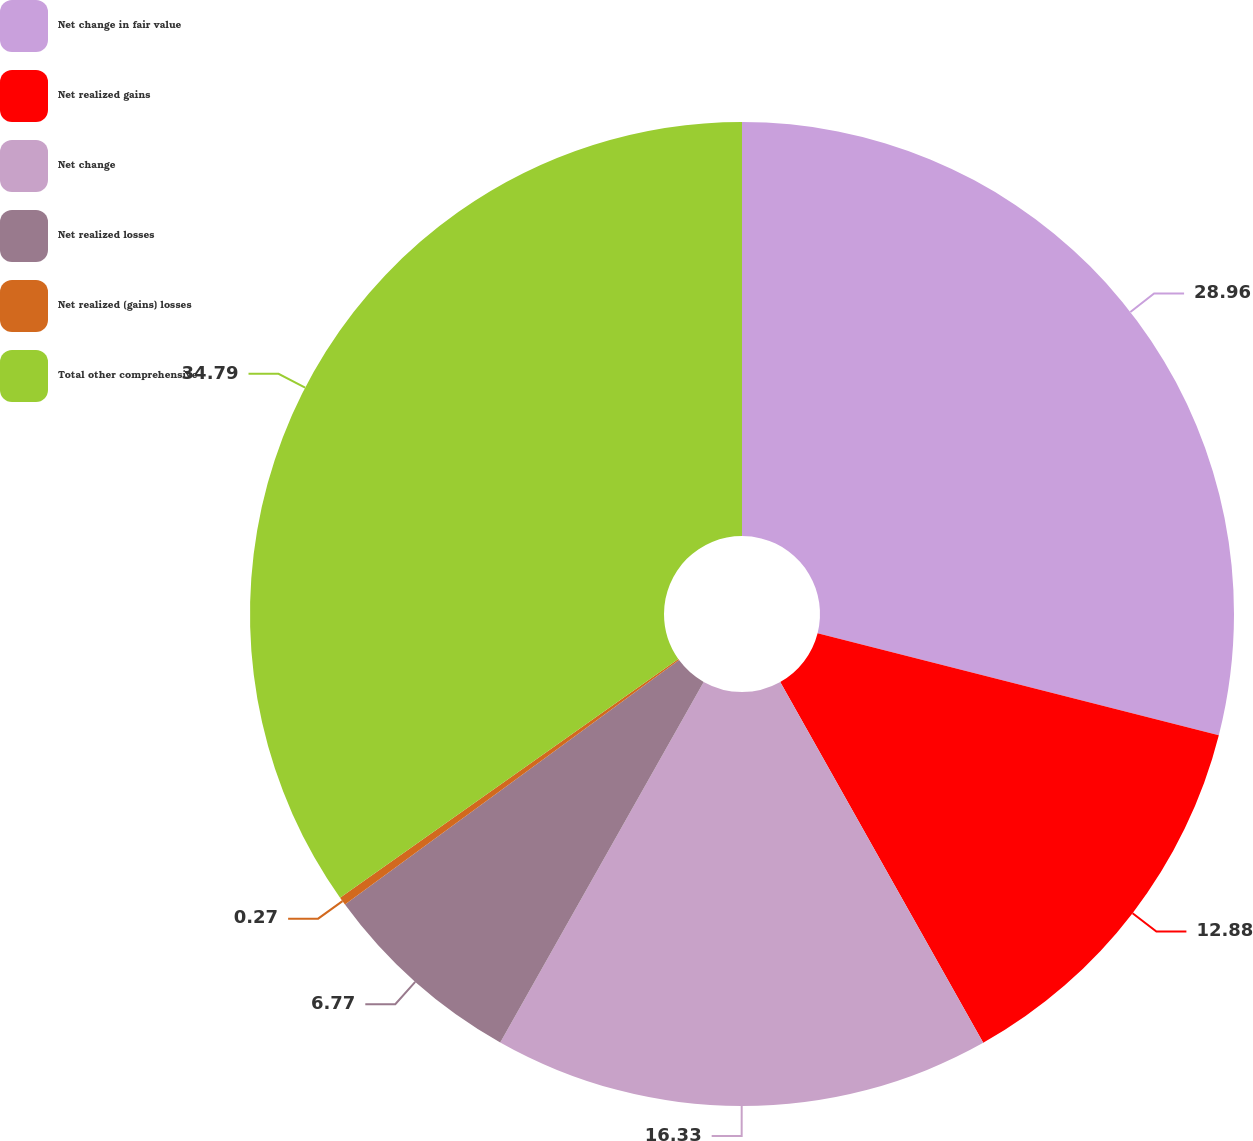<chart> <loc_0><loc_0><loc_500><loc_500><pie_chart><fcel>Net change in fair value<fcel>Net realized gains<fcel>Net change<fcel>Net realized losses<fcel>Net realized (gains) losses<fcel>Total other comprehensive<nl><fcel>28.96%<fcel>12.88%<fcel>16.33%<fcel>6.77%<fcel>0.27%<fcel>34.78%<nl></chart> 